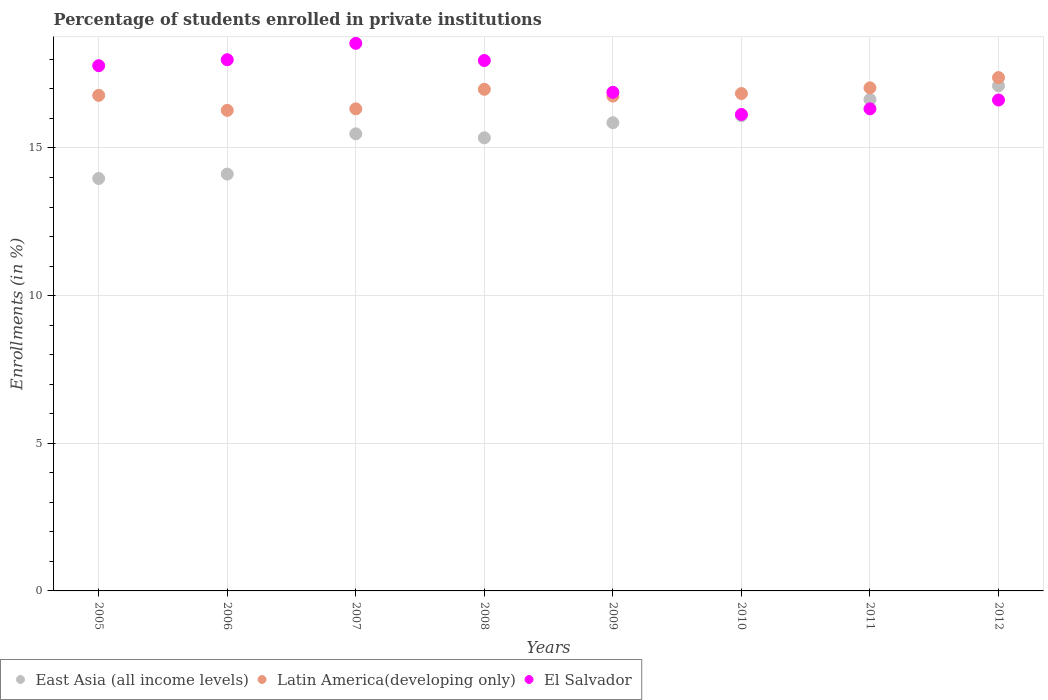How many different coloured dotlines are there?
Offer a terse response. 3. What is the percentage of trained teachers in East Asia (all income levels) in 2011?
Your response must be concise. 16.64. Across all years, what is the maximum percentage of trained teachers in Latin America(developing only)?
Provide a short and direct response. 17.38. Across all years, what is the minimum percentage of trained teachers in El Salvador?
Provide a succinct answer. 16.14. In which year was the percentage of trained teachers in El Salvador minimum?
Provide a short and direct response. 2010. What is the total percentage of trained teachers in El Salvador in the graph?
Your response must be concise. 138.25. What is the difference between the percentage of trained teachers in East Asia (all income levels) in 2005 and that in 2007?
Offer a very short reply. -1.51. What is the difference between the percentage of trained teachers in East Asia (all income levels) in 2011 and the percentage of trained teachers in El Salvador in 2009?
Your answer should be very brief. -0.24. What is the average percentage of trained teachers in East Asia (all income levels) per year?
Provide a short and direct response. 15.57. In the year 2005, what is the difference between the percentage of trained teachers in Latin America(developing only) and percentage of trained teachers in El Salvador?
Offer a very short reply. -1. In how many years, is the percentage of trained teachers in Latin America(developing only) greater than 1 %?
Your response must be concise. 8. What is the ratio of the percentage of trained teachers in Latin America(developing only) in 2005 to that in 2012?
Provide a succinct answer. 0.97. Is the percentage of trained teachers in Latin America(developing only) in 2006 less than that in 2008?
Ensure brevity in your answer.  Yes. Is the difference between the percentage of trained teachers in Latin America(developing only) in 2005 and 2011 greater than the difference between the percentage of trained teachers in El Salvador in 2005 and 2011?
Your answer should be very brief. No. What is the difference between the highest and the second highest percentage of trained teachers in Latin America(developing only)?
Your answer should be very brief. 0.35. What is the difference between the highest and the lowest percentage of trained teachers in East Asia (all income levels)?
Offer a terse response. 3.14. Is the sum of the percentage of trained teachers in El Salvador in 2008 and 2010 greater than the maximum percentage of trained teachers in Latin America(developing only) across all years?
Make the answer very short. Yes. Is it the case that in every year, the sum of the percentage of trained teachers in East Asia (all income levels) and percentage of trained teachers in Latin America(developing only)  is greater than the percentage of trained teachers in El Salvador?
Offer a very short reply. Yes. Does the percentage of trained teachers in El Salvador monotonically increase over the years?
Offer a terse response. No. What is the difference between two consecutive major ticks on the Y-axis?
Provide a succinct answer. 5. Are the values on the major ticks of Y-axis written in scientific E-notation?
Your response must be concise. No. How many legend labels are there?
Your response must be concise. 3. How are the legend labels stacked?
Offer a very short reply. Horizontal. What is the title of the graph?
Ensure brevity in your answer.  Percentage of students enrolled in private institutions. Does "Serbia" appear as one of the legend labels in the graph?
Offer a very short reply. No. What is the label or title of the Y-axis?
Offer a terse response. Enrollments (in %). What is the Enrollments (in %) of East Asia (all income levels) in 2005?
Make the answer very short. 13.97. What is the Enrollments (in %) in Latin America(developing only) in 2005?
Keep it short and to the point. 16.78. What is the Enrollments (in %) in El Salvador in 2005?
Your answer should be very brief. 17.79. What is the Enrollments (in %) in East Asia (all income levels) in 2006?
Your answer should be very brief. 14.12. What is the Enrollments (in %) in Latin America(developing only) in 2006?
Your answer should be compact. 16.27. What is the Enrollments (in %) of El Salvador in 2006?
Your response must be concise. 17.99. What is the Enrollments (in %) in East Asia (all income levels) in 2007?
Keep it short and to the point. 15.48. What is the Enrollments (in %) of Latin America(developing only) in 2007?
Your answer should be very brief. 16.32. What is the Enrollments (in %) in El Salvador in 2007?
Provide a short and direct response. 18.54. What is the Enrollments (in %) of East Asia (all income levels) in 2008?
Your answer should be very brief. 15.34. What is the Enrollments (in %) in Latin America(developing only) in 2008?
Your answer should be compact. 16.99. What is the Enrollments (in %) in El Salvador in 2008?
Provide a short and direct response. 17.96. What is the Enrollments (in %) in East Asia (all income levels) in 2009?
Your response must be concise. 15.86. What is the Enrollments (in %) in Latin America(developing only) in 2009?
Your answer should be compact. 16.76. What is the Enrollments (in %) in El Salvador in 2009?
Make the answer very short. 16.88. What is the Enrollments (in %) in East Asia (all income levels) in 2010?
Keep it short and to the point. 16.09. What is the Enrollments (in %) in Latin America(developing only) in 2010?
Ensure brevity in your answer.  16.84. What is the Enrollments (in %) of El Salvador in 2010?
Offer a very short reply. 16.14. What is the Enrollments (in %) of East Asia (all income levels) in 2011?
Provide a succinct answer. 16.64. What is the Enrollments (in %) in Latin America(developing only) in 2011?
Your answer should be compact. 17.04. What is the Enrollments (in %) of El Salvador in 2011?
Ensure brevity in your answer.  16.32. What is the Enrollments (in %) of East Asia (all income levels) in 2012?
Keep it short and to the point. 17.1. What is the Enrollments (in %) in Latin America(developing only) in 2012?
Give a very brief answer. 17.38. What is the Enrollments (in %) of El Salvador in 2012?
Offer a terse response. 16.62. Across all years, what is the maximum Enrollments (in %) of East Asia (all income levels)?
Your response must be concise. 17.1. Across all years, what is the maximum Enrollments (in %) in Latin America(developing only)?
Provide a short and direct response. 17.38. Across all years, what is the maximum Enrollments (in %) in El Salvador?
Your answer should be compact. 18.54. Across all years, what is the minimum Enrollments (in %) in East Asia (all income levels)?
Your answer should be very brief. 13.97. Across all years, what is the minimum Enrollments (in %) of Latin America(developing only)?
Ensure brevity in your answer.  16.27. Across all years, what is the minimum Enrollments (in %) in El Salvador?
Give a very brief answer. 16.14. What is the total Enrollments (in %) in East Asia (all income levels) in the graph?
Your answer should be very brief. 124.6. What is the total Enrollments (in %) in Latin America(developing only) in the graph?
Offer a terse response. 134.39. What is the total Enrollments (in %) in El Salvador in the graph?
Your response must be concise. 138.25. What is the difference between the Enrollments (in %) in East Asia (all income levels) in 2005 and that in 2006?
Keep it short and to the point. -0.15. What is the difference between the Enrollments (in %) of Latin America(developing only) in 2005 and that in 2006?
Provide a short and direct response. 0.51. What is the difference between the Enrollments (in %) of El Salvador in 2005 and that in 2006?
Your answer should be very brief. -0.2. What is the difference between the Enrollments (in %) of East Asia (all income levels) in 2005 and that in 2007?
Offer a terse response. -1.51. What is the difference between the Enrollments (in %) in Latin America(developing only) in 2005 and that in 2007?
Your answer should be compact. 0.46. What is the difference between the Enrollments (in %) in El Salvador in 2005 and that in 2007?
Offer a terse response. -0.76. What is the difference between the Enrollments (in %) of East Asia (all income levels) in 2005 and that in 2008?
Provide a short and direct response. -1.38. What is the difference between the Enrollments (in %) of Latin America(developing only) in 2005 and that in 2008?
Offer a terse response. -0.2. What is the difference between the Enrollments (in %) in El Salvador in 2005 and that in 2008?
Your response must be concise. -0.18. What is the difference between the Enrollments (in %) in East Asia (all income levels) in 2005 and that in 2009?
Ensure brevity in your answer.  -1.89. What is the difference between the Enrollments (in %) of Latin America(developing only) in 2005 and that in 2009?
Your answer should be very brief. 0.03. What is the difference between the Enrollments (in %) in El Salvador in 2005 and that in 2009?
Your response must be concise. 0.9. What is the difference between the Enrollments (in %) in East Asia (all income levels) in 2005 and that in 2010?
Your answer should be very brief. -2.13. What is the difference between the Enrollments (in %) of Latin America(developing only) in 2005 and that in 2010?
Give a very brief answer. -0.06. What is the difference between the Enrollments (in %) of El Salvador in 2005 and that in 2010?
Keep it short and to the point. 1.65. What is the difference between the Enrollments (in %) in East Asia (all income levels) in 2005 and that in 2011?
Your answer should be very brief. -2.68. What is the difference between the Enrollments (in %) in Latin America(developing only) in 2005 and that in 2011?
Provide a succinct answer. -0.25. What is the difference between the Enrollments (in %) of El Salvador in 2005 and that in 2011?
Offer a very short reply. 1.46. What is the difference between the Enrollments (in %) of East Asia (all income levels) in 2005 and that in 2012?
Offer a terse response. -3.14. What is the difference between the Enrollments (in %) in Latin America(developing only) in 2005 and that in 2012?
Ensure brevity in your answer.  -0.6. What is the difference between the Enrollments (in %) in El Salvador in 2005 and that in 2012?
Your answer should be very brief. 1.16. What is the difference between the Enrollments (in %) in East Asia (all income levels) in 2006 and that in 2007?
Provide a succinct answer. -1.36. What is the difference between the Enrollments (in %) in Latin America(developing only) in 2006 and that in 2007?
Make the answer very short. -0.05. What is the difference between the Enrollments (in %) in El Salvador in 2006 and that in 2007?
Your response must be concise. -0.55. What is the difference between the Enrollments (in %) of East Asia (all income levels) in 2006 and that in 2008?
Give a very brief answer. -1.23. What is the difference between the Enrollments (in %) of Latin America(developing only) in 2006 and that in 2008?
Provide a succinct answer. -0.71. What is the difference between the Enrollments (in %) in El Salvador in 2006 and that in 2008?
Your response must be concise. 0.03. What is the difference between the Enrollments (in %) of East Asia (all income levels) in 2006 and that in 2009?
Offer a very short reply. -1.74. What is the difference between the Enrollments (in %) in Latin America(developing only) in 2006 and that in 2009?
Your answer should be very brief. -0.48. What is the difference between the Enrollments (in %) of El Salvador in 2006 and that in 2009?
Keep it short and to the point. 1.1. What is the difference between the Enrollments (in %) of East Asia (all income levels) in 2006 and that in 2010?
Offer a terse response. -1.98. What is the difference between the Enrollments (in %) in Latin America(developing only) in 2006 and that in 2010?
Keep it short and to the point. -0.57. What is the difference between the Enrollments (in %) in El Salvador in 2006 and that in 2010?
Ensure brevity in your answer.  1.85. What is the difference between the Enrollments (in %) in East Asia (all income levels) in 2006 and that in 2011?
Ensure brevity in your answer.  -2.53. What is the difference between the Enrollments (in %) in Latin America(developing only) in 2006 and that in 2011?
Your answer should be very brief. -0.76. What is the difference between the Enrollments (in %) of El Salvador in 2006 and that in 2011?
Your answer should be compact. 1.66. What is the difference between the Enrollments (in %) of East Asia (all income levels) in 2006 and that in 2012?
Offer a very short reply. -2.99. What is the difference between the Enrollments (in %) of Latin America(developing only) in 2006 and that in 2012?
Offer a very short reply. -1.11. What is the difference between the Enrollments (in %) in El Salvador in 2006 and that in 2012?
Keep it short and to the point. 1.36. What is the difference between the Enrollments (in %) of East Asia (all income levels) in 2007 and that in 2008?
Provide a succinct answer. 0.13. What is the difference between the Enrollments (in %) in Latin America(developing only) in 2007 and that in 2008?
Your answer should be compact. -0.66. What is the difference between the Enrollments (in %) in El Salvador in 2007 and that in 2008?
Give a very brief answer. 0.58. What is the difference between the Enrollments (in %) of East Asia (all income levels) in 2007 and that in 2009?
Your answer should be very brief. -0.38. What is the difference between the Enrollments (in %) in Latin America(developing only) in 2007 and that in 2009?
Provide a short and direct response. -0.43. What is the difference between the Enrollments (in %) of El Salvador in 2007 and that in 2009?
Provide a succinct answer. 1.66. What is the difference between the Enrollments (in %) of East Asia (all income levels) in 2007 and that in 2010?
Your response must be concise. -0.61. What is the difference between the Enrollments (in %) in Latin America(developing only) in 2007 and that in 2010?
Provide a short and direct response. -0.52. What is the difference between the Enrollments (in %) in El Salvador in 2007 and that in 2010?
Provide a short and direct response. 2.41. What is the difference between the Enrollments (in %) of East Asia (all income levels) in 2007 and that in 2011?
Ensure brevity in your answer.  -1.16. What is the difference between the Enrollments (in %) in Latin America(developing only) in 2007 and that in 2011?
Your response must be concise. -0.71. What is the difference between the Enrollments (in %) in El Salvador in 2007 and that in 2011?
Your answer should be very brief. 2.22. What is the difference between the Enrollments (in %) in East Asia (all income levels) in 2007 and that in 2012?
Your response must be concise. -1.63. What is the difference between the Enrollments (in %) in Latin America(developing only) in 2007 and that in 2012?
Your answer should be very brief. -1.06. What is the difference between the Enrollments (in %) in El Salvador in 2007 and that in 2012?
Ensure brevity in your answer.  1.92. What is the difference between the Enrollments (in %) in East Asia (all income levels) in 2008 and that in 2009?
Your response must be concise. -0.51. What is the difference between the Enrollments (in %) of Latin America(developing only) in 2008 and that in 2009?
Ensure brevity in your answer.  0.23. What is the difference between the Enrollments (in %) of El Salvador in 2008 and that in 2009?
Make the answer very short. 1.08. What is the difference between the Enrollments (in %) of East Asia (all income levels) in 2008 and that in 2010?
Ensure brevity in your answer.  -0.75. What is the difference between the Enrollments (in %) in Latin America(developing only) in 2008 and that in 2010?
Make the answer very short. 0.14. What is the difference between the Enrollments (in %) of El Salvador in 2008 and that in 2010?
Ensure brevity in your answer.  1.83. What is the difference between the Enrollments (in %) of East Asia (all income levels) in 2008 and that in 2011?
Keep it short and to the point. -1.3. What is the difference between the Enrollments (in %) in Latin America(developing only) in 2008 and that in 2011?
Your answer should be very brief. -0.05. What is the difference between the Enrollments (in %) of El Salvador in 2008 and that in 2011?
Your answer should be very brief. 1.64. What is the difference between the Enrollments (in %) of East Asia (all income levels) in 2008 and that in 2012?
Provide a succinct answer. -1.76. What is the difference between the Enrollments (in %) of Latin America(developing only) in 2008 and that in 2012?
Provide a short and direct response. -0.4. What is the difference between the Enrollments (in %) in El Salvador in 2008 and that in 2012?
Keep it short and to the point. 1.34. What is the difference between the Enrollments (in %) in East Asia (all income levels) in 2009 and that in 2010?
Make the answer very short. -0.24. What is the difference between the Enrollments (in %) in Latin America(developing only) in 2009 and that in 2010?
Make the answer very short. -0.09. What is the difference between the Enrollments (in %) in El Salvador in 2009 and that in 2010?
Make the answer very short. 0.75. What is the difference between the Enrollments (in %) in East Asia (all income levels) in 2009 and that in 2011?
Keep it short and to the point. -0.79. What is the difference between the Enrollments (in %) of Latin America(developing only) in 2009 and that in 2011?
Ensure brevity in your answer.  -0.28. What is the difference between the Enrollments (in %) of El Salvador in 2009 and that in 2011?
Your answer should be compact. 0.56. What is the difference between the Enrollments (in %) in East Asia (all income levels) in 2009 and that in 2012?
Provide a succinct answer. -1.25. What is the difference between the Enrollments (in %) of Latin America(developing only) in 2009 and that in 2012?
Give a very brief answer. -0.63. What is the difference between the Enrollments (in %) of El Salvador in 2009 and that in 2012?
Provide a short and direct response. 0.26. What is the difference between the Enrollments (in %) in East Asia (all income levels) in 2010 and that in 2011?
Ensure brevity in your answer.  -0.55. What is the difference between the Enrollments (in %) of Latin America(developing only) in 2010 and that in 2011?
Your answer should be compact. -0.19. What is the difference between the Enrollments (in %) in El Salvador in 2010 and that in 2011?
Keep it short and to the point. -0.19. What is the difference between the Enrollments (in %) of East Asia (all income levels) in 2010 and that in 2012?
Give a very brief answer. -1.01. What is the difference between the Enrollments (in %) of Latin America(developing only) in 2010 and that in 2012?
Offer a very short reply. -0.54. What is the difference between the Enrollments (in %) of El Salvador in 2010 and that in 2012?
Offer a very short reply. -0.49. What is the difference between the Enrollments (in %) of East Asia (all income levels) in 2011 and that in 2012?
Offer a terse response. -0.46. What is the difference between the Enrollments (in %) in Latin America(developing only) in 2011 and that in 2012?
Offer a terse response. -0.35. What is the difference between the Enrollments (in %) of El Salvador in 2011 and that in 2012?
Your response must be concise. -0.3. What is the difference between the Enrollments (in %) in East Asia (all income levels) in 2005 and the Enrollments (in %) in Latin America(developing only) in 2006?
Ensure brevity in your answer.  -2.31. What is the difference between the Enrollments (in %) in East Asia (all income levels) in 2005 and the Enrollments (in %) in El Salvador in 2006?
Give a very brief answer. -4.02. What is the difference between the Enrollments (in %) in Latin America(developing only) in 2005 and the Enrollments (in %) in El Salvador in 2006?
Offer a terse response. -1.21. What is the difference between the Enrollments (in %) of East Asia (all income levels) in 2005 and the Enrollments (in %) of Latin America(developing only) in 2007?
Keep it short and to the point. -2.36. What is the difference between the Enrollments (in %) of East Asia (all income levels) in 2005 and the Enrollments (in %) of El Salvador in 2007?
Ensure brevity in your answer.  -4.58. What is the difference between the Enrollments (in %) in Latin America(developing only) in 2005 and the Enrollments (in %) in El Salvador in 2007?
Offer a very short reply. -1.76. What is the difference between the Enrollments (in %) of East Asia (all income levels) in 2005 and the Enrollments (in %) of Latin America(developing only) in 2008?
Provide a short and direct response. -3.02. What is the difference between the Enrollments (in %) in East Asia (all income levels) in 2005 and the Enrollments (in %) in El Salvador in 2008?
Provide a succinct answer. -4. What is the difference between the Enrollments (in %) in Latin America(developing only) in 2005 and the Enrollments (in %) in El Salvador in 2008?
Ensure brevity in your answer.  -1.18. What is the difference between the Enrollments (in %) of East Asia (all income levels) in 2005 and the Enrollments (in %) of Latin America(developing only) in 2009?
Your answer should be very brief. -2.79. What is the difference between the Enrollments (in %) of East Asia (all income levels) in 2005 and the Enrollments (in %) of El Salvador in 2009?
Your answer should be compact. -2.92. What is the difference between the Enrollments (in %) in Latin America(developing only) in 2005 and the Enrollments (in %) in El Salvador in 2009?
Your answer should be very brief. -0.1. What is the difference between the Enrollments (in %) in East Asia (all income levels) in 2005 and the Enrollments (in %) in Latin America(developing only) in 2010?
Provide a succinct answer. -2.88. What is the difference between the Enrollments (in %) of East Asia (all income levels) in 2005 and the Enrollments (in %) of El Salvador in 2010?
Your answer should be compact. -2.17. What is the difference between the Enrollments (in %) of Latin America(developing only) in 2005 and the Enrollments (in %) of El Salvador in 2010?
Your answer should be very brief. 0.65. What is the difference between the Enrollments (in %) of East Asia (all income levels) in 2005 and the Enrollments (in %) of Latin America(developing only) in 2011?
Give a very brief answer. -3.07. What is the difference between the Enrollments (in %) in East Asia (all income levels) in 2005 and the Enrollments (in %) in El Salvador in 2011?
Make the answer very short. -2.36. What is the difference between the Enrollments (in %) in Latin America(developing only) in 2005 and the Enrollments (in %) in El Salvador in 2011?
Your response must be concise. 0.46. What is the difference between the Enrollments (in %) of East Asia (all income levels) in 2005 and the Enrollments (in %) of Latin America(developing only) in 2012?
Make the answer very short. -3.42. What is the difference between the Enrollments (in %) in East Asia (all income levels) in 2005 and the Enrollments (in %) in El Salvador in 2012?
Offer a terse response. -2.66. What is the difference between the Enrollments (in %) in Latin America(developing only) in 2005 and the Enrollments (in %) in El Salvador in 2012?
Provide a succinct answer. 0.16. What is the difference between the Enrollments (in %) in East Asia (all income levels) in 2006 and the Enrollments (in %) in Latin America(developing only) in 2007?
Your answer should be compact. -2.21. What is the difference between the Enrollments (in %) of East Asia (all income levels) in 2006 and the Enrollments (in %) of El Salvador in 2007?
Make the answer very short. -4.43. What is the difference between the Enrollments (in %) in Latin America(developing only) in 2006 and the Enrollments (in %) in El Salvador in 2007?
Offer a terse response. -2.27. What is the difference between the Enrollments (in %) of East Asia (all income levels) in 2006 and the Enrollments (in %) of Latin America(developing only) in 2008?
Your answer should be very brief. -2.87. What is the difference between the Enrollments (in %) of East Asia (all income levels) in 2006 and the Enrollments (in %) of El Salvador in 2008?
Make the answer very short. -3.85. What is the difference between the Enrollments (in %) in Latin America(developing only) in 2006 and the Enrollments (in %) in El Salvador in 2008?
Your response must be concise. -1.69. What is the difference between the Enrollments (in %) in East Asia (all income levels) in 2006 and the Enrollments (in %) in Latin America(developing only) in 2009?
Make the answer very short. -2.64. What is the difference between the Enrollments (in %) of East Asia (all income levels) in 2006 and the Enrollments (in %) of El Salvador in 2009?
Your response must be concise. -2.77. What is the difference between the Enrollments (in %) in Latin America(developing only) in 2006 and the Enrollments (in %) in El Salvador in 2009?
Your answer should be compact. -0.61. What is the difference between the Enrollments (in %) of East Asia (all income levels) in 2006 and the Enrollments (in %) of Latin America(developing only) in 2010?
Give a very brief answer. -2.73. What is the difference between the Enrollments (in %) in East Asia (all income levels) in 2006 and the Enrollments (in %) in El Salvador in 2010?
Provide a short and direct response. -2.02. What is the difference between the Enrollments (in %) in Latin America(developing only) in 2006 and the Enrollments (in %) in El Salvador in 2010?
Your response must be concise. 0.14. What is the difference between the Enrollments (in %) in East Asia (all income levels) in 2006 and the Enrollments (in %) in Latin America(developing only) in 2011?
Ensure brevity in your answer.  -2.92. What is the difference between the Enrollments (in %) of East Asia (all income levels) in 2006 and the Enrollments (in %) of El Salvador in 2011?
Give a very brief answer. -2.21. What is the difference between the Enrollments (in %) in Latin America(developing only) in 2006 and the Enrollments (in %) in El Salvador in 2011?
Provide a short and direct response. -0.05. What is the difference between the Enrollments (in %) in East Asia (all income levels) in 2006 and the Enrollments (in %) in Latin America(developing only) in 2012?
Provide a succinct answer. -3.27. What is the difference between the Enrollments (in %) of East Asia (all income levels) in 2006 and the Enrollments (in %) of El Salvador in 2012?
Your response must be concise. -2.51. What is the difference between the Enrollments (in %) of Latin America(developing only) in 2006 and the Enrollments (in %) of El Salvador in 2012?
Your answer should be compact. -0.35. What is the difference between the Enrollments (in %) in East Asia (all income levels) in 2007 and the Enrollments (in %) in Latin America(developing only) in 2008?
Offer a terse response. -1.51. What is the difference between the Enrollments (in %) of East Asia (all income levels) in 2007 and the Enrollments (in %) of El Salvador in 2008?
Offer a very short reply. -2.48. What is the difference between the Enrollments (in %) of Latin America(developing only) in 2007 and the Enrollments (in %) of El Salvador in 2008?
Your answer should be very brief. -1.64. What is the difference between the Enrollments (in %) in East Asia (all income levels) in 2007 and the Enrollments (in %) in Latin America(developing only) in 2009?
Offer a terse response. -1.28. What is the difference between the Enrollments (in %) of East Asia (all income levels) in 2007 and the Enrollments (in %) of El Salvador in 2009?
Ensure brevity in your answer.  -1.41. What is the difference between the Enrollments (in %) in Latin America(developing only) in 2007 and the Enrollments (in %) in El Salvador in 2009?
Provide a succinct answer. -0.56. What is the difference between the Enrollments (in %) of East Asia (all income levels) in 2007 and the Enrollments (in %) of Latin America(developing only) in 2010?
Offer a very short reply. -1.36. What is the difference between the Enrollments (in %) in East Asia (all income levels) in 2007 and the Enrollments (in %) in El Salvador in 2010?
Provide a short and direct response. -0.66. What is the difference between the Enrollments (in %) of Latin America(developing only) in 2007 and the Enrollments (in %) of El Salvador in 2010?
Offer a terse response. 0.19. What is the difference between the Enrollments (in %) of East Asia (all income levels) in 2007 and the Enrollments (in %) of Latin America(developing only) in 2011?
Your answer should be very brief. -1.56. What is the difference between the Enrollments (in %) of East Asia (all income levels) in 2007 and the Enrollments (in %) of El Salvador in 2011?
Give a very brief answer. -0.85. What is the difference between the Enrollments (in %) of Latin America(developing only) in 2007 and the Enrollments (in %) of El Salvador in 2011?
Your response must be concise. -0. What is the difference between the Enrollments (in %) in East Asia (all income levels) in 2007 and the Enrollments (in %) in Latin America(developing only) in 2012?
Your response must be concise. -1.9. What is the difference between the Enrollments (in %) in East Asia (all income levels) in 2007 and the Enrollments (in %) in El Salvador in 2012?
Your answer should be very brief. -1.15. What is the difference between the Enrollments (in %) in Latin America(developing only) in 2007 and the Enrollments (in %) in El Salvador in 2012?
Give a very brief answer. -0.3. What is the difference between the Enrollments (in %) of East Asia (all income levels) in 2008 and the Enrollments (in %) of Latin America(developing only) in 2009?
Your answer should be very brief. -1.41. What is the difference between the Enrollments (in %) in East Asia (all income levels) in 2008 and the Enrollments (in %) in El Salvador in 2009?
Ensure brevity in your answer.  -1.54. What is the difference between the Enrollments (in %) of Latin America(developing only) in 2008 and the Enrollments (in %) of El Salvador in 2009?
Ensure brevity in your answer.  0.1. What is the difference between the Enrollments (in %) in East Asia (all income levels) in 2008 and the Enrollments (in %) in Latin America(developing only) in 2010?
Ensure brevity in your answer.  -1.5. What is the difference between the Enrollments (in %) in East Asia (all income levels) in 2008 and the Enrollments (in %) in El Salvador in 2010?
Your answer should be very brief. -0.79. What is the difference between the Enrollments (in %) in Latin America(developing only) in 2008 and the Enrollments (in %) in El Salvador in 2010?
Make the answer very short. 0.85. What is the difference between the Enrollments (in %) of East Asia (all income levels) in 2008 and the Enrollments (in %) of Latin America(developing only) in 2011?
Your answer should be very brief. -1.69. What is the difference between the Enrollments (in %) in East Asia (all income levels) in 2008 and the Enrollments (in %) in El Salvador in 2011?
Offer a very short reply. -0.98. What is the difference between the Enrollments (in %) in Latin America(developing only) in 2008 and the Enrollments (in %) in El Salvador in 2011?
Offer a terse response. 0.66. What is the difference between the Enrollments (in %) in East Asia (all income levels) in 2008 and the Enrollments (in %) in Latin America(developing only) in 2012?
Provide a succinct answer. -2.04. What is the difference between the Enrollments (in %) of East Asia (all income levels) in 2008 and the Enrollments (in %) of El Salvador in 2012?
Your response must be concise. -1.28. What is the difference between the Enrollments (in %) of Latin America(developing only) in 2008 and the Enrollments (in %) of El Salvador in 2012?
Ensure brevity in your answer.  0.36. What is the difference between the Enrollments (in %) of East Asia (all income levels) in 2009 and the Enrollments (in %) of Latin America(developing only) in 2010?
Your answer should be very brief. -0.99. What is the difference between the Enrollments (in %) of East Asia (all income levels) in 2009 and the Enrollments (in %) of El Salvador in 2010?
Make the answer very short. -0.28. What is the difference between the Enrollments (in %) in Latin America(developing only) in 2009 and the Enrollments (in %) in El Salvador in 2010?
Offer a terse response. 0.62. What is the difference between the Enrollments (in %) in East Asia (all income levels) in 2009 and the Enrollments (in %) in Latin America(developing only) in 2011?
Give a very brief answer. -1.18. What is the difference between the Enrollments (in %) of East Asia (all income levels) in 2009 and the Enrollments (in %) of El Salvador in 2011?
Provide a succinct answer. -0.47. What is the difference between the Enrollments (in %) of Latin America(developing only) in 2009 and the Enrollments (in %) of El Salvador in 2011?
Give a very brief answer. 0.43. What is the difference between the Enrollments (in %) in East Asia (all income levels) in 2009 and the Enrollments (in %) in Latin America(developing only) in 2012?
Give a very brief answer. -1.53. What is the difference between the Enrollments (in %) in East Asia (all income levels) in 2009 and the Enrollments (in %) in El Salvador in 2012?
Your answer should be very brief. -0.77. What is the difference between the Enrollments (in %) in Latin America(developing only) in 2009 and the Enrollments (in %) in El Salvador in 2012?
Your answer should be compact. 0.13. What is the difference between the Enrollments (in %) in East Asia (all income levels) in 2010 and the Enrollments (in %) in Latin America(developing only) in 2011?
Your answer should be compact. -0.94. What is the difference between the Enrollments (in %) in East Asia (all income levels) in 2010 and the Enrollments (in %) in El Salvador in 2011?
Offer a very short reply. -0.23. What is the difference between the Enrollments (in %) in Latin America(developing only) in 2010 and the Enrollments (in %) in El Salvador in 2011?
Provide a succinct answer. 0.52. What is the difference between the Enrollments (in %) of East Asia (all income levels) in 2010 and the Enrollments (in %) of Latin America(developing only) in 2012?
Your response must be concise. -1.29. What is the difference between the Enrollments (in %) of East Asia (all income levels) in 2010 and the Enrollments (in %) of El Salvador in 2012?
Ensure brevity in your answer.  -0.53. What is the difference between the Enrollments (in %) in Latin America(developing only) in 2010 and the Enrollments (in %) in El Salvador in 2012?
Give a very brief answer. 0.22. What is the difference between the Enrollments (in %) in East Asia (all income levels) in 2011 and the Enrollments (in %) in Latin America(developing only) in 2012?
Ensure brevity in your answer.  -0.74. What is the difference between the Enrollments (in %) of East Asia (all income levels) in 2011 and the Enrollments (in %) of El Salvador in 2012?
Make the answer very short. 0.02. What is the difference between the Enrollments (in %) in Latin America(developing only) in 2011 and the Enrollments (in %) in El Salvador in 2012?
Keep it short and to the point. 0.41. What is the average Enrollments (in %) in East Asia (all income levels) per year?
Offer a terse response. 15.57. What is the average Enrollments (in %) of Latin America(developing only) per year?
Your response must be concise. 16.8. What is the average Enrollments (in %) of El Salvador per year?
Your answer should be compact. 17.28. In the year 2005, what is the difference between the Enrollments (in %) of East Asia (all income levels) and Enrollments (in %) of Latin America(developing only)?
Offer a terse response. -2.82. In the year 2005, what is the difference between the Enrollments (in %) in East Asia (all income levels) and Enrollments (in %) in El Salvador?
Keep it short and to the point. -3.82. In the year 2005, what is the difference between the Enrollments (in %) in Latin America(developing only) and Enrollments (in %) in El Salvador?
Offer a very short reply. -1. In the year 2006, what is the difference between the Enrollments (in %) of East Asia (all income levels) and Enrollments (in %) of Latin America(developing only)?
Your response must be concise. -2.16. In the year 2006, what is the difference between the Enrollments (in %) of East Asia (all income levels) and Enrollments (in %) of El Salvador?
Ensure brevity in your answer.  -3.87. In the year 2006, what is the difference between the Enrollments (in %) in Latin America(developing only) and Enrollments (in %) in El Salvador?
Make the answer very short. -1.72. In the year 2007, what is the difference between the Enrollments (in %) in East Asia (all income levels) and Enrollments (in %) in Latin America(developing only)?
Give a very brief answer. -0.85. In the year 2007, what is the difference between the Enrollments (in %) in East Asia (all income levels) and Enrollments (in %) in El Salvador?
Ensure brevity in your answer.  -3.06. In the year 2007, what is the difference between the Enrollments (in %) of Latin America(developing only) and Enrollments (in %) of El Salvador?
Offer a very short reply. -2.22. In the year 2008, what is the difference between the Enrollments (in %) in East Asia (all income levels) and Enrollments (in %) in Latin America(developing only)?
Provide a succinct answer. -1.64. In the year 2008, what is the difference between the Enrollments (in %) in East Asia (all income levels) and Enrollments (in %) in El Salvador?
Give a very brief answer. -2.62. In the year 2008, what is the difference between the Enrollments (in %) in Latin America(developing only) and Enrollments (in %) in El Salvador?
Give a very brief answer. -0.98. In the year 2009, what is the difference between the Enrollments (in %) of East Asia (all income levels) and Enrollments (in %) of Latin America(developing only)?
Provide a succinct answer. -0.9. In the year 2009, what is the difference between the Enrollments (in %) of East Asia (all income levels) and Enrollments (in %) of El Salvador?
Give a very brief answer. -1.03. In the year 2009, what is the difference between the Enrollments (in %) of Latin America(developing only) and Enrollments (in %) of El Salvador?
Keep it short and to the point. -0.13. In the year 2010, what is the difference between the Enrollments (in %) of East Asia (all income levels) and Enrollments (in %) of Latin America(developing only)?
Give a very brief answer. -0.75. In the year 2010, what is the difference between the Enrollments (in %) of East Asia (all income levels) and Enrollments (in %) of El Salvador?
Keep it short and to the point. -0.04. In the year 2010, what is the difference between the Enrollments (in %) in Latin America(developing only) and Enrollments (in %) in El Salvador?
Your response must be concise. 0.71. In the year 2011, what is the difference between the Enrollments (in %) of East Asia (all income levels) and Enrollments (in %) of Latin America(developing only)?
Offer a very short reply. -0.39. In the year 2011, what is the difference between the Enrollments (in %) of East Asia (all income levels) and Enrollments (in %) of El Salvador?
Your response must be concise. 0.32. In the year 2011, what is the difference between the Enrollments (in %) of Latin America(developing only) and Enrollments (in %) of El Salvador?
Your response must be concise. 0.71. In the year 2012, what is the difference between the Enrollments (in %) of East Asia (all income levels) and Enrollments (in %) of Latin America(developing only)?
Ensure brevity in your answer.  -0.28. In the year 2012, what is the difference between the Enrollments (in %) in East Asia (all income levels) and Enrollments (in %) in El Salvador?
Ensure brevity in your answer.  0.48. In the year 2012, what is the difference between the Enrollments (in %) of Latin America(developing only) and Enrollments (in %) of El Salvador?
Your answer should be very brief. 0.76. What is the ratio of the Enrollments (in %) in East Asia (all income levels) in 2005 to that in 2006?
Keep it short and to the point. 0.99. What is the ratio of the Enrollments (in %) in Latin America(developing only) in 2005 to that in 2006?
Make the answer very short. 1.03. What is the ratio of the Enrollments (in %) in East Asia (all income levels) in 2005 to that in 2007?
Keep it short and to the point. 0.9. What is the ratio of the Enrollments (in %) in Latin America(developing only) in 2005 to that in 2007?
Your answer should be very brief. 1.03. What is the ratio of the Enrollments (in %) of El Salvador in 2005 to that in 2007?
Keep it short and to the point. 0.96. What is the ratio of the Enrollments (in %) of East Asia (all income levels) in 2005 to that in 2008?
Keep it short and to the point. 0.91. What is the ratio of the Enrollments (in %) of Latin America(developing only) in 2005 to that in 2008?
Offer a terse response. 0.99. What is the ratio of the Enrollments (in %) in El Salvador in 2005 to that in 2008?
Offer a very short reply. 0.99. What is the ratio of the Enrollments (in %) in East Asia (all income levels) in 2005 to that in 2009?
Your answer should be very brief. 0.88. What is the ratio of the Enrollments (in %) of El Salvador in 2005 to that in 2009?
Keep it short and to the point. 1.05. What is the ratio of the Enrollments (in %) in East Asia (all income levels) in 2005 to that in 2010?
Offer a very short reply. 0.87. What is the ratio of the Enrollments (in %) in Latin America(developing only) in 2005 to that in 2010?
Make the answer very short. 1. What is the ratio of the Enrollments (in %) of El Salvador in 2005 to that in 2010?
Ensure brevity in your answer.  1.1. What is the ratio of the Enrollments (in %) in East Asia (all income levels) in 2005 to that in 2011?
Offer a very short reply. 0.84. What is the ratio of the Enrollments (in %) in Latin America(developing only) in 2005 to that in 2011?
Keep it short and to the point. 0.99. What is the ratio of the Enrollments (in %) in El Salvador in 2005 to that in 2011?
Provide a short and direct response. 1.09. What is the ratio of the Enrollments (in %) of East Asia (all income levels) in 2005 to that in 2012?
Your answer should be compact. 0.82. What is the ratio of the Enrollments (in %) of Latin America(developing only) in 2005 to that in 2012?
Ensure brevity in your answer.  0.97. What is the ratio of the Enrollments (in %) in El Salvador in 2005 to that in 2012?
Ensure brevity in your answer.  1.07. What is the ratio of the Enrollments (in %) of East Asia (all income levels) in 2006 to that in 2007?
Offer a terse response. 0.91. What is the ratio of the Enrollments (in %) of Latin America(developing only) in 2006 to that in 2007?
Give a very brief answer. 1. What is the ratio of the Enrollments (in %) in El Salvador in 2006 to that in 2007?
Your response must be concise. 0.97. What is the ratio of the Enrollments (in %) of East Asia (all income levels) in 2006 to that in 2008?
Ensure brevity in your answer.  0.92. What is the ratio of the Enrollments (in %) of Latin America(developing only) in 2006 to that in 2008?
Ensure brevity in your answer.  0.96. What is the ratio of the Enrollments (in %) of East Asia (all income levels) in 2006 to that in 2009?
Provide a succinct answer. 0.89. What is the ratio of the Enrollments (in %) of Latin America(developing only) in 2006 to that in 2009?
Give a very brief answer. 0.97. What is the ratio of the Enrollments (in %) of El Salvador in 2006 to that in 2009?
Offer a very short reply. 1.07. What is the ratio of the Enrollments (in %) in East Asia (all income levels) in 2006 to that in 2010?
Ensure brevity in your answer.  0.88. What is the ratio of the Enrollments (in %) in Latin America(developing only) in 2006 to that in 2010?
Make the answer very short. 0.97. What is the ratio of the Enrollments (in %) of El Salvador in 2006 to that in 2010?
Ensure brevity in your answer.  1.11. What is the ratio of the Enrollments (in %) of East Asia (all income levels) in 2006 to that in 2011?
Make the answer very short. 0.85. What is the ratio of the Enrollments (in %) in Latin America(developing only) in 2006 to that in 2011?
Provide a short and direct response. 0.96. What is the ratio of the Enrollments (in %) of El Salvador in 2006 to that in 2011?
Provide a short and direct response. 1.1. What is the ratio of the Enrollments (in %) of East Asia (all income levels) in 2006 to that in 2012?
Provide a succinct answer. 0.83. What is the ratio of the Enrollments (in %) in Latin America(developing only) in 2006 to that in 2012?
Your answer should be very brief. 0.94. What is the ratio of the Enrollments (in %) in El Salvador in 2006 to that in 2012?
Keep it short and to the point. 1.08. What is the ratio of the Enrollments (in %) in East Asia (all income levels) in 2007 to that in 2008?
Keep it short and to the point. 1.01. What is the ratio of the Enrollments (in %) in Latin America(developing only) in 2007 to that in 2008?
Give a very brief answer. 0.96. What is the ratio of the Enrollments (in %) in El Salvador in 2007 to that in 2008?
Offer a terse response. 1.03. What is the ratio of the Enrollments (in %) of East Asia (all income levels) in 2007 to that in 2009?
Offer a terse response. 0.98. What is the ratio of the Enrollments (in %) in Latin America(developing only) in 2007 to that in 2009?
Ensure brevity in your answer.  0.97. What is the ratio of the Enrollments (in %) of El Salvador in 2007 to that in 2009?
Offer a very short reply. 1.1. What is the ratio of the Enrollments (in %) of East Asia (all income levels) in 2007 to that in 2010?
Ensure brevity in your answer.  0.96. What is the ratio of the Enrollments (in %) of Latin America(developing only) in 2007 to that in 2010?
Give a very brief answer. 0.97. What is the ratio of the Enrollments (in %) of El Salvador in 2007 to that in 2010?
Keep it short and to the point. 1.15. What is the ratio of the Enrollments (in %) of East Asia (all income levels) in 2007 to that in 2011?
Offer a terse response. 0.93. What is the ratio of the Enrollments (in %) of Latin America(developing only) in 2007 to that in 2011?
Offer a very short reply. 0.96. What is the ratio of the Enrollments (in %) in El Salvador in 2007 to that in 2011?
Your answer should be very brief. 1.14. What is the ratio of the Enrollments (in %) in East Asia (all income levels) in 2007 to that in 2012?
Provide a short and direct response. 0.91. What is the ratio of the Enrollments (in %) in Latin America(developing only) in 2007 to that in 2012?
Provide a succinct answer. 0.94. What is the ratio of the Enrollments (in %) in El Salvador in 2007 to that in 2012?
Provide a succinct answer. 1.12. What is the ratio of the Enrollments (in %) in East Asia (all income levels) in 2008 to that in 2009?
Your answer should be compact. 0.97. What is the ratio of the Enrollments (in %) in Latin America(developing only) in 2008 to that in 2009?
Provide a short and direct response. 1.01. What is the ratio of the Enrollments (in %) in El Salvador in 2008 to that in 2009?
Ensure brevity in your answer.  1.06. What is the ratio of the Enrollments (in %) of East Asia (all income levels) in 2008 to that in 2010?
Your response must be concise. 0.95. What is the ratio of the Enrollments (in %) of Latin America(developing only) in 2008 to that in 2010?
Offer a terse response. 1.01. What is the ratio of the Enrollments (in %) of El Salvador in 2008 to that in 2010?
Ensure brevity in your answer.  1.11. What is the ratio of the Enrollments (in %) in East Asia (all income levels) in 2008 to that in 2011?
Provide a short and direct response. 0.92. What is the ratio of the Enrollments (in %) in El Salvador in 2008 to that in 2011?
Provide a short and direct response. 1.1. What is the ratio of the Enrollments (in %) of East Asia (all income levels) in 2008 to that in 2012?
Offer a terse response. 0.9. What is the ratio of the Enrollments (in %) in Latin America(developing only) in 2008 to that in 2012?
Offer a terse response. 0.98. What is the ratio of the Enrollments (in %) of El Salvador in 2008 to that in 2012?
Ensure brevity in your answer.  1.08. What is the ratio of the Enrollments (in %) in El Salvador in 2009 to that in 2010?
Your answer should be very brief. 1.05. What is the ratio of the Enrollments (in %) in East Asia (all income levels) in 2009 to that in 2011?
Keep it short and to the point. 0.95. What is the ratio of the Enrollments (in %) in Latin America(developing only) in 2009 to that in 2011?
Your answer should be very brief. 0.98. What is the ratio of the Enrollments (in %) in El Salvador in 2009 to that in 2011?
Keep it short and to the point. 1.03. What is the ratio of the Enrollments (in %) in East Asia (all income levels) in 2009 to that in 2012?
Offer a terse response. 0.93. What is the ratio of the Enrollments (in %) in Latin America(developing only) in 2009 to that in 2012?
Keep it short and to the point. 0.96. What is the ratio of the Enrollments (in %) of El Salvador in 2009 to that in 2012?
Your response must be concise. 1.02. What is the ratio of the Enrollments (in %) of East Asia (all income levels) in 2010 to that in 2011?
Offer a very short reply. 0.97. What is the ratio of the Enrollments (in %) of Latin America(developing only) in 2010 to that in 2011?
Provide a succinct answer. 0.99. What is the ratio of the Enrollments (in %) in El Salvador in 2010 to that in 2011?
Provide a succinct answer. 0.99. What is the ratio of the Enrollments (in %) of East Asia (all income levels) in 2010 to that in 2012?
Make the answer very short. 0.94. What is the ratio of the Enrollments (in %) in Latin America(developing only) in 2010 to that in 2012?
Give a very brief answer. 0.97. What is the ratio of the Enrollments (in %) of El Salvador in 2010 to that in 2012?
Give a very brief answer. 0.97. What is the ratio of the Enrollments (in %) in East Asia (all income levels) in 2011 to that in 2012?
Your response must be concise. 0.97. What is the difference between the highest and the second highest Enrollments (in %) of East Asia (all income levels)?
Provide a succinct answer. 0.46. What is the difference between the highest and the second highest Enrollments (in %) of Latin America(developing only)?
Your answer should be compact. 0.35. What is the difference between the highest and the second highest Enrollments (in %) in El Salvador?
Provide a short and direct response. 0.55. What is the difference between the highest and the lowest Enrollments (in %) of East Asia (all income levels)?
Offer a terse response. 3.14. What is the difference between the highest and the lowest Enrollments (in %) of Latin America(developing only)?
Offer a very short reply. 1.11. What is the difference between the highest and the lowest Enrollments (in %) in El Salvador?
Keep it short and to the point. 2.41. 